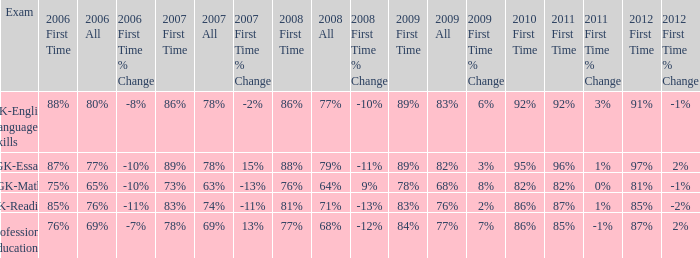What is the percentage for all in 2007 when all in 2006 was 65%? 63%. 